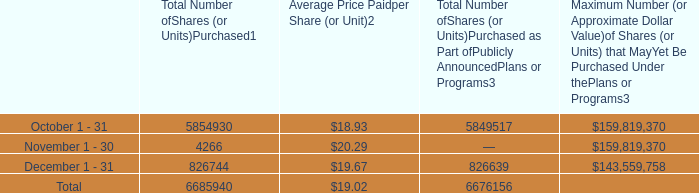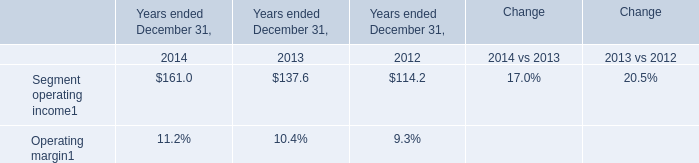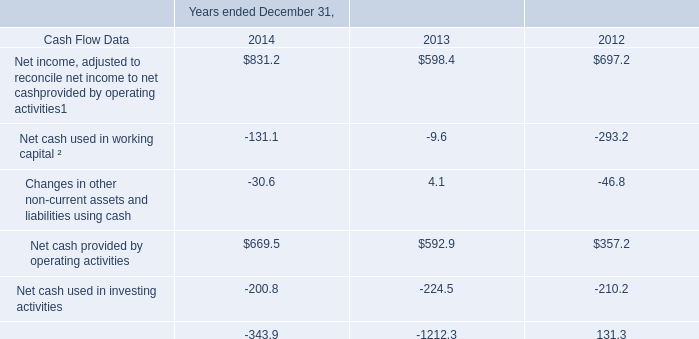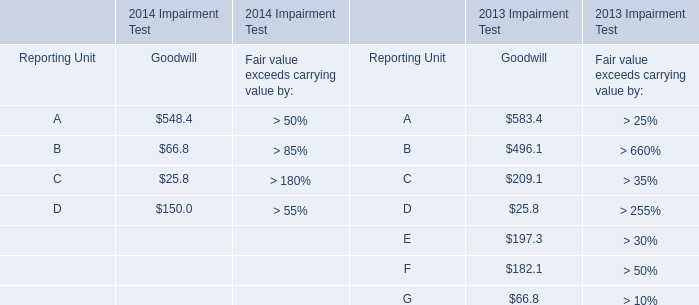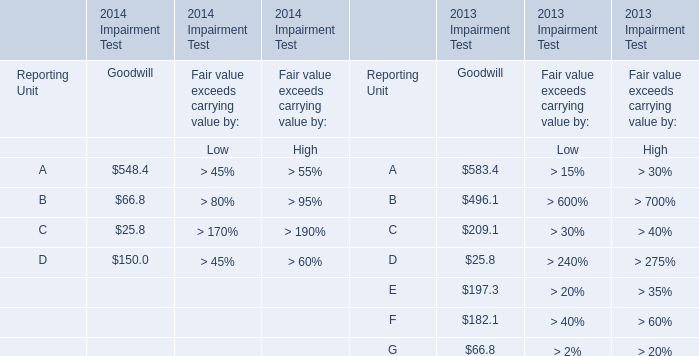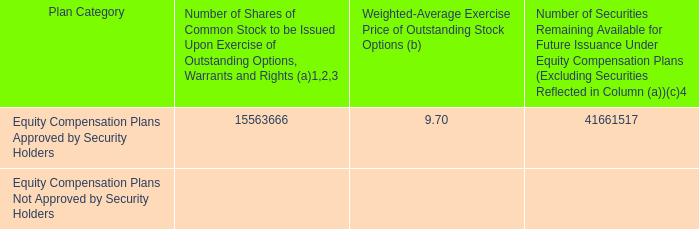For 2013 Impairment Test,what's the value of the Goodwill of E? 
Answer: 197.3. 